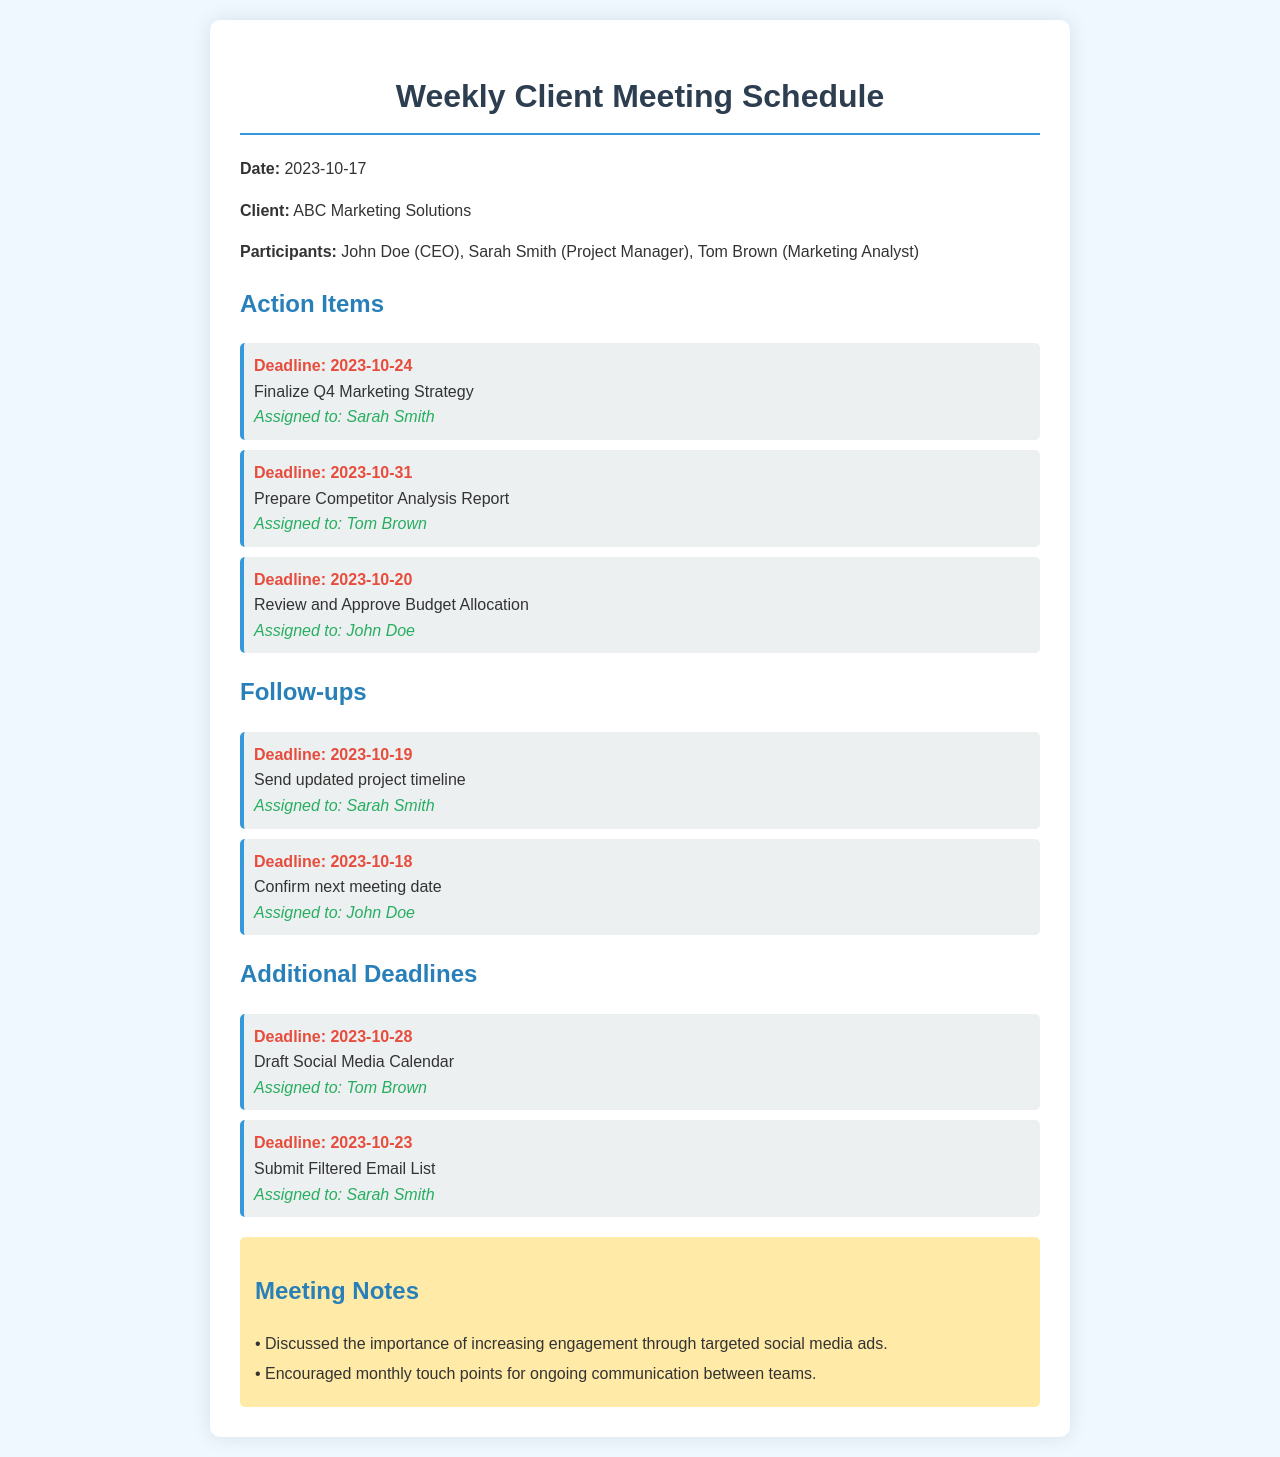What is the date of the meeting? The date of the meeting is indicated in the document.
Answer: 2023-10-17 Who is responsible for finalizing the Q4 Marketing Strategy? The document lists the assigned personnel for each action item.
Answer: Sarah Smith What is the deadline for preparing the Competitor Analysis Report? The deadline is specified under the action items in the document.
Answer: 2023-10-31 How many participants were in the meeting? The number of participants is mentioned in the introduction of the document.
Answer: 3 What was discussed regarding social media? The document contains notes detailing the discussion points from the meeting.
Answer: Increasing engagement through targeted social media ads What is the next deadline after October 24? The document lists deadlines in chronological order; the next one is after October 24.
Answer: 2023-10-28 Who was assigned to review and approve the Budget Allocation? The document specifies who is responsible for each action item.
Answer: John Doe When is the next meeting date to be confirmed? The deadline for confirming the next meeting date is mentioned in the follow-ups section.
Answer: 2023-10-18 What is one of the follow-up tasks? The follow-up tasks are listed under a specific section in the document.
Answer: Send updated project timeline 